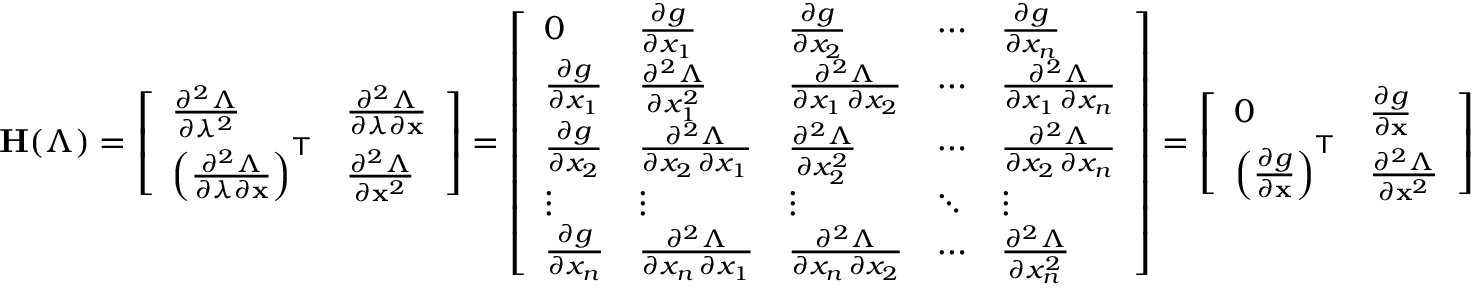<formula> <loc_0><loc_0><loc_500><loc_500>H ( \Lambda ) = { \left [ \begin{array} { l l } { { \frac { \partial ^ { 2 } \Lambda } { \partial \lambda ^ { 2 } } } } & { { \frac { \partial ^ { 2 } \Lambda } { \partial \lambda \partial x } } } \\ { \left ( { \frac { \partial ^ { 2 } \Lambda } { \partial \lambda \partial x } } \right ) ^ { T } } & { { \frac { \partial ^ { 2 } \Lambda } { \partial x ^ { 2 } } } } \end{array} \right ] } = { \left [ \begin{array} { l l l l l } { 0 } & { { \frac { \partial g } { \partial x _ { 1 } } } } & { { \frac { \partial g } { \partial x _ { 2 } } } } & { \cdots } & { { \frac { \partial g } { \partial x _ { n } } } } \\ { { \frac { \partial g } { \partial x _ { 1 } } } } & { { \frac { \partial ^ { 2 } \Lambda } { \partial x _ { 1 } ^ { 2 } } } } & { { \frac { \partial ^ { 2 } \Lambda } { \partial x _ { 1 } \, \partial x _ { 2 } } } } & { \cdots } & { { \frac { \partial ^ { 2 } \Lambda } { \partial x _ { 1 } \, \partial x _ { n } } } } \\ { { \frac { \partial g } { \partial x _ { 2 } } } } & { { \frac { \partial ^ { 2 } \Lambda } { \partial x _ { 2 } \, \partial x _ { 1 } } } } & { { \frac { \partial ^ { 2 } \Lambda } { \partial x _ { 2 } ^ { 2 } } } } & { \cdots } & { { \frac { \partial ^ { 2 } \Lambda } { \partial x _ { 2 } \, \partial x _ { n } } } } \\ { \vdots } & { \vdots } & { \vdots } & { \ddots } & { \vdots } \\ { { \frac { \partial g } { \partial x _ { n } } } } & { { \frac { \partial ^ { 2 } \Lambda } { \partial x _ { n } \, \partial x _ { 1 } } } } & { { \frac { \partial ^ { 2 } \Lambda } { \partial x _ { n } \, \partial x _ { 2 } } } } & { \cdots } & { { \frac { \partial ^ { 2 } \Lambda } { \partial x _ { n } ^ { 2 } } } } \end{array} \right ] } = { \left [ \begin{array} { l l } { 0 } & { { \frac { \partial g } { \partial x } } } \\ { \left ( { \frac { \partial g } { \partial x } } \right ) ^ { T } } & { { \frac { \partial ^ { 2 } \Lambda } { \partial x ^ { 2 } } } } \end{array} \right ] }</formula> 